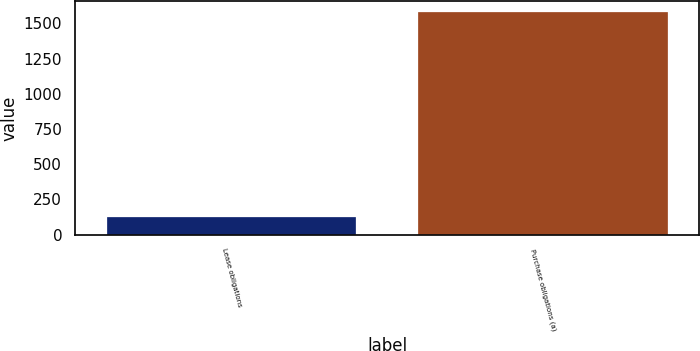Convert chart to OTSL. <chart><loc_0><loc_0><loc_500><loc_500><bar_chart><fcel>Lease obligations<fcel>Purchase obligations (a)<nl><fcel>128<fcel>1579<nl></chart> 